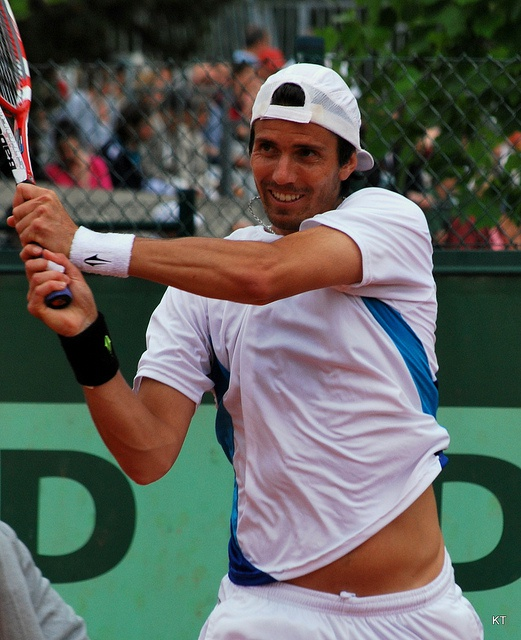Describe the objects in this image and their specific colors. I can see people in brown, darkgray, lightgray, and maroon tones, people in brown, darkgray, and gray tones, tennis racket in brown, black, gray, lightgray, and darkgray tones, and people in brown, black, maroon, and gray tones in this image. 